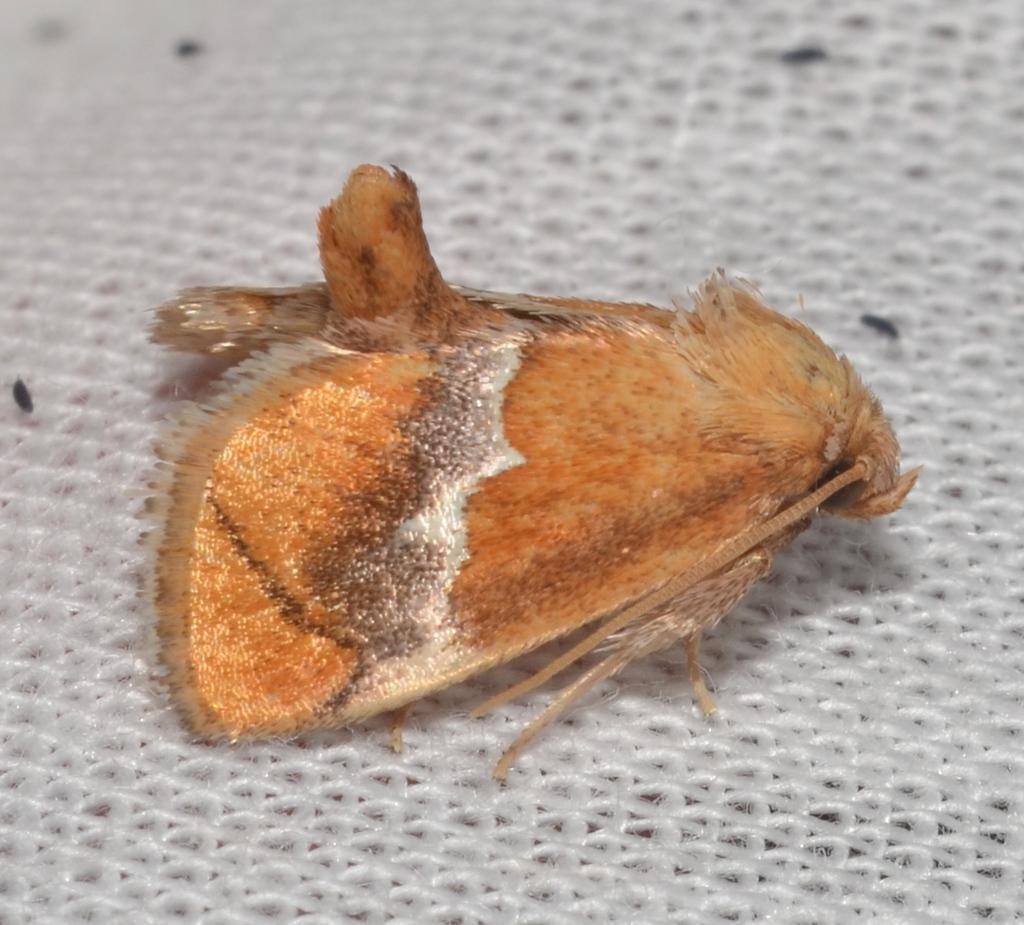In one or two sentences, can you explain what this image depicts? This picture shows a fly. It is white and brown in color and we see a white background. 